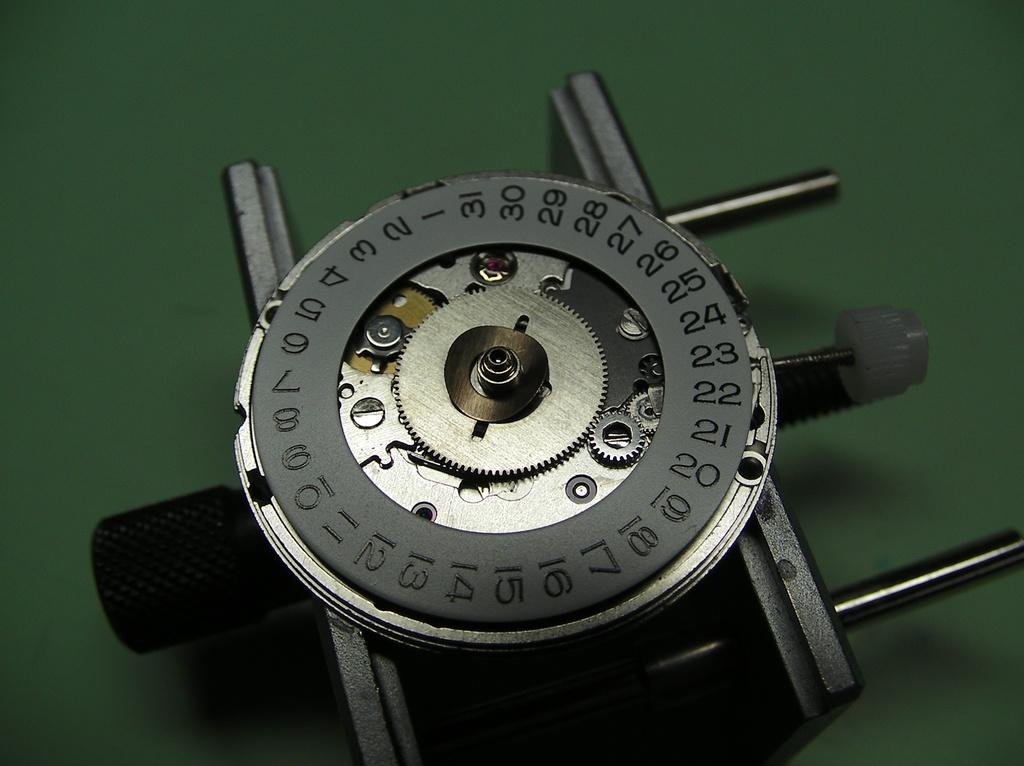<image>
Describe the image concisely. A round mechanism numbered one to thirty one laying on a green surface. 